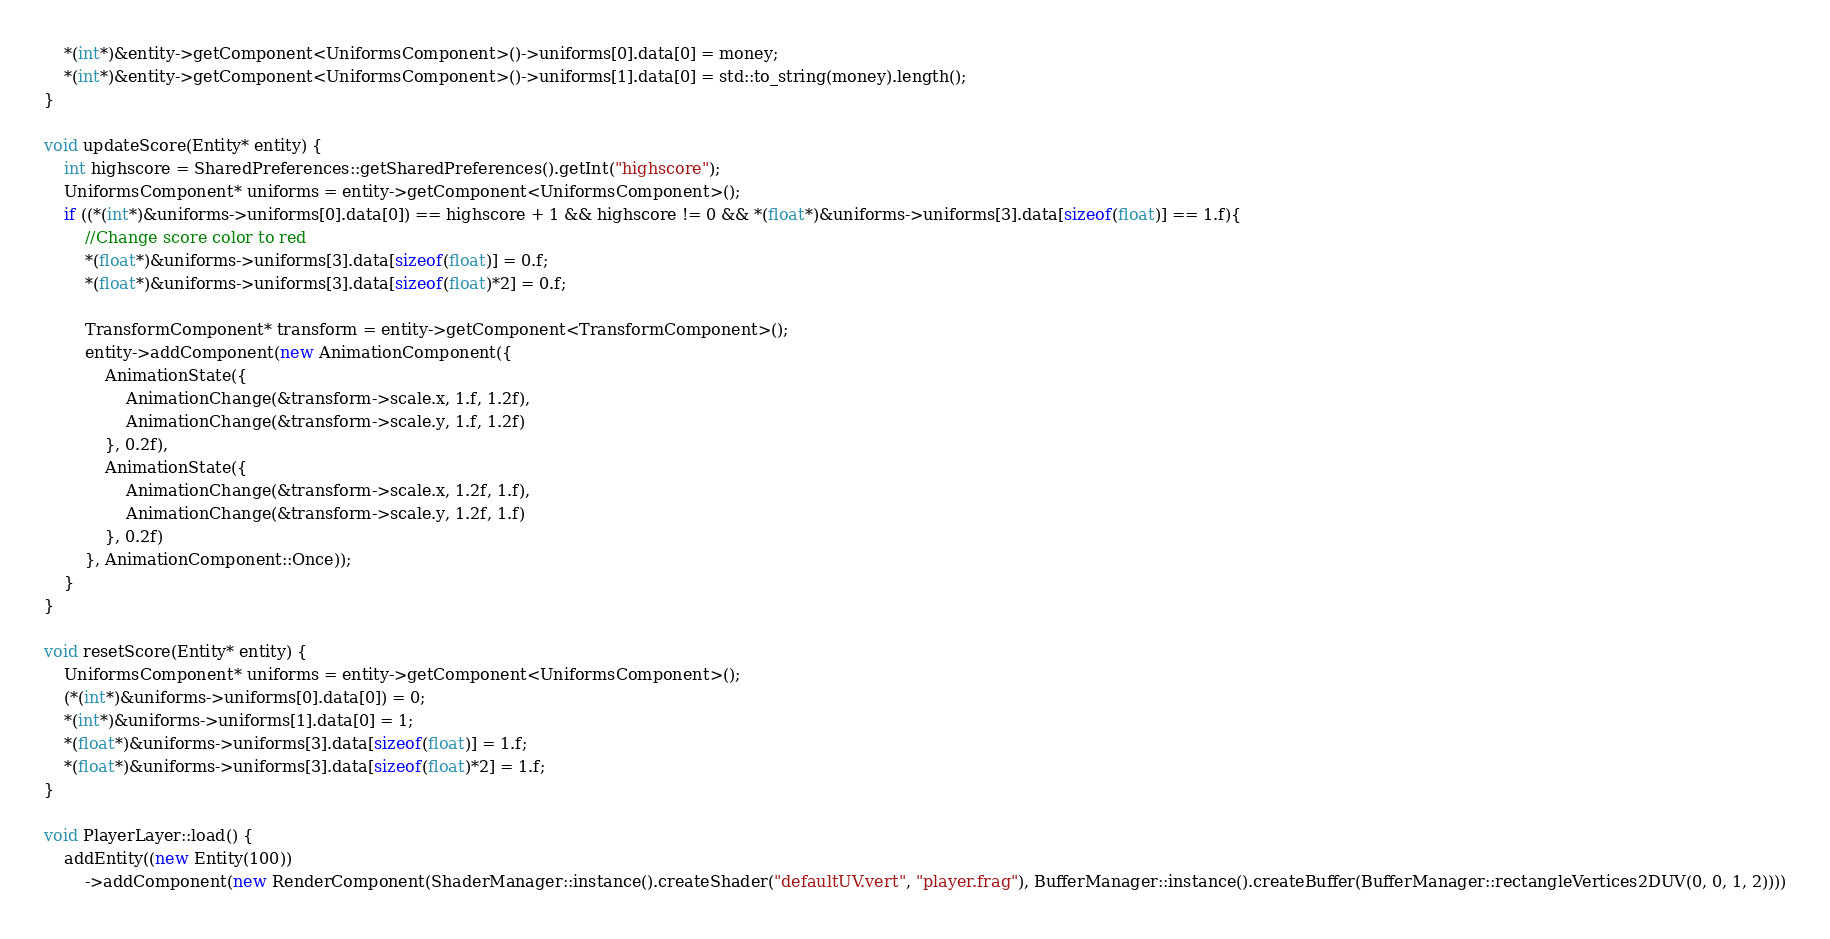<code> <loc_0><loc_0><loc_500><loc_500><_C++_>	*(int*)&entity->getComponent<UniformsComponent>()->uniforms[0].data[0] = money;
	*(int*)&entity->getComponent<UniformsComponent>()->uniforms[1].data[0] = std::to_string(money).length();
}

void updateScore(Entity* entity) {
	int highscore = SharedPreferences::getSharedPreferences().getInt("highscore");
	UniformsComponent* uniforms = entity->getComponent<UniformsComponent>();
	if ((*(int*)&uniforms->uniforms[0].data[0]) == highscore + 1 && highscore != 0 && *(float*)&uniforms->uniforms[3].data[sizeof(float)] == 1.f){
		//Change score color to red
		*(float*)&uniforms->uniforms[3].data[sizeof(float)] = 0.f;
		*(float*)&uniforms->uniforms[3].data[sizeof(float)*2] = 0.f;

		TransformComponent* transform = entity->getComponent<TransformComponent>();
		entity->addComponent(new AnimationComponent({
			AnimationState({
				AnimationChange(&transform->scale.x, 1.f, 1.2f),
				AnimationChange(&transform->scale.y, 1.f, 1.2f)
			}, 0.2f),
			AnimationState({
				AnimationChange(&transform->scale.x, 1.2f, 1.f),
				AnimationChange(&transform->scale.y, 1.2f, 1.f)
			}, 0.2f)
		}, AnimationComponent::Once));
	}
}

void resetScore(Entity* entity) {
	UniformsComponent* uniforms = entity->getComponent<UniformsComponent>();
	(*(int*)&uniforms->uniforms[0].data[0]) = 0;
	*(int*)&uniforms->uniforms[1].data[0] = 1;
	*(float*)&uniforms->uniforms[3].data[sizeof(float)] = 1.f;
	*(float*)&uniforms->uniforms[3].data[sizeof(float)*2] = 1.f;
}

void PlayerLayer::load() {
	addEntity((new Entity(100))
		->addComponent(new RenderComponent(ShaderManager::instance().createShader("defaultUV.vert", "player.frag"), BufferManager::instance().createBuffer(BufferManager::rectangleVertices2DUV(0, 0, 1, 2))))</code> 